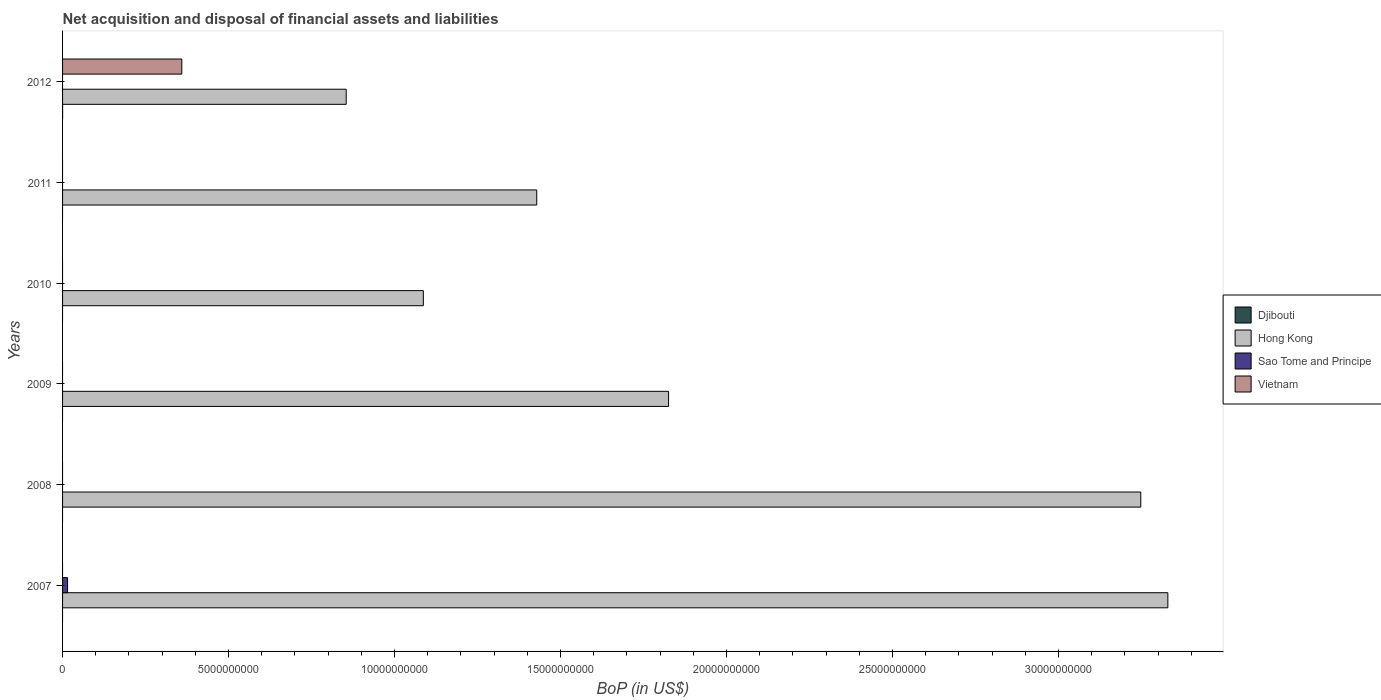Are the number of bars on each tick of the Y-axis equal?
Give a very brief answer. No. How many bars are there on the 2nd tick from the top?
Your answer should be very brief. 1. What is the label of the 2nd group of bars from the top?
Keep it short and to the point. 2011. In how many cases, is the number of bars for a given year not equal to the number of legend labels?
Ensure brevity in your answer.  6. What is the Balance of Payments in Hong Kong in 2010?
Give a very brief answer. 1.09e+1. Across all years, what is the maximum Balance of Payments in Vietnam?
Make the answer very short. 3.59e+09. Across all years, what is the minimum Balance of Payments in Hong Kong?
Offer a terse response. 8.54e+09. In which year was the Balance of Payments in Sao Tome and Principe maximum?
Keep it short and to the point. 2007. What is the total Balance of Payments in Djibouti in the graph?
Your response must be concise. 9.34e+05. What is the difference between the Balance of Payments in Hong Kong in 2007 and that in 2011?
Make the answer very short. 1.90e+1. What is the difference between the Balance of Payments in Hong Kong in 2009 and the Balance of Payments in Djibouti in 2007?
Provide a succinct answer. 1.83e+1. What is the average Balance of Payments in Sao Tome and Principe per year?
Provide a succinct answer. 2.51e+07. In how many years, is the Balance of Payments in Djibouti greater than 14000000000 US$?
Your answer should be compact. 0. What is the ratio of the Balance of Payments in Hong Kong in 2008 to that in 2011?
Your answer should be very brief. 2.27. What is the difference between the highest and the lowest Balance of Payments in Sao Tome and Principe?
Offer a terse response. 1.50e+08. Is the sum of the Balance of Payments in Hong Kong in 2008 and 2011 greater than the maximum Balance of Payments in Sao Tome and Principe across all years?
Offer a very short reply. Yes. Is it the case that in every year, the sum of the Balance of Payments in Djibouti and Balance of Payments in Hong Kong is greater than the Balance of Payments in Vietnam?
Ensure brevity in your answer.  Yes. How many bars are there?
Make the answer very short. 9. Are all the bars in the graph horizontal?
Offer a terse response. Yes. What is the difference between two consecutive major ticks on the X-axis?
Your response must be concise. 5.00e+09. Does the graph contain grids?
Offer a terse response. No. Where does the legend appear in the graph?
Give a very brief answer. Center right. How many legend labels are there?
Give a very brief answer. 4. What is the title of the graph?
Make the answer very short. Net acquisition and disposal of financial assets and liabilities. What is the label or title of the X-axis?
Make the answer very short. BoP (in US$). What is the BoP (in US$) in Hong Kong in 2007?
Provide a succinct answer. 3.33e+1. What is the BoP (in US$) in Sao Tome and Principe in 2007?
Your answer should be compact. 1.50e+08. What is the BoP (in US$) in Hong Kong in 2008?
Your response must be concise. 3.25e+1. What is the BoP (in US$) of Sao Tome and Principe in 2008?
Make the answer very short. 0. What is the BoP (in US$) in Vietnam in 2008?
Offer a very short reply. 0. What is the BoP (in US$) in Djibouti in 2009?
Ensure brevity in your answer.  0. What is the BoP (in US$) in Hong Kong in 2009?
Give a very brief answer. 1.83e+1. What is the BoP (in US$) in Vietnam in 2009?
Give a very brief answer. 0. What is the BoP (in US$) in Hong Kong in 2010?
Offer a terse response. 1.09e+1. What is the BoP (in US$) in Sao Tome and Principe in 2010?
Provide a succinct answer. 0. What is the BoP (in US$) of Djibouti in 2011?
Provide a short and direct response. 0. What is the BoP (in US$) of Hong Kong in 2011?
Offer a very short reply. 1.43e+1. What is the BoP (in US$) of Djibouti in 2012?
Give a very brief answer. 9.34e+05. What is the BoP (in US$) in Hong Kong in 2012?
Ensure brevity in your answer.  8.54e+09. What is the BoP (in US$) of Vietnam in 2012?
Give a very brief answer. 3.59e+09. Across all years, what is the maximum BoP (in US$) of Djibouti?
Your response must be concise. 9.34e+05. Across all years, what is the maximum BoP (in US$) of Hong Kong?
Your answer should be very brief. 3.33e+1. Across all years, what is the maximum BoP (in US$) of Sao Tome and Principe?
Offer a very short reply. 1.50e+08. Across all years, what is the maximum BoP (in US$) of Vietnam?
Provide a succinct answer. 3.59e+09. Across all years, what is the minimum BoP (in US$) of Djibouti?
Your answer should be compact. 0. Across all years, what is the minimum BoP (in US$) in Hong Kong?
Keep it short and to the point. 8.54e+09. Across all years, what is the minimum BoP (in US$) of Sao Tome and Principe?
Provide a short and direct response. 0. What is the total BoP (in US$) in Djibouti in the graph?
Make the answer very short. 9.34e+05. What is the total BoP (in US$) of Hong Kong in the graph?
Make the answer very short. 1.18e+11. What is the total BoP (in US$) in Sao Tome and Principe in the graph?
Provide a succinct answer. 1.50e+08. What is the total BoP (in US$) in Vietnam in the graph?
Offer a terse response. 3.59e+09. What is the difference between the BoP (in US$) in Hong Kong in 2007 and that in 2008?
Provide a succinct answer. 8.15e+08. What is the difference between the BoP (in US$) of Hong Kong in 2007 and that in 2009?
Provide a short and direct response. 1.50e+1. What is the difference between the BoP (in US$) in Hong Kong in 2007 and that in 2010?
Your answer should be compact. 2.24e+1. What is the difference between the BoP (in US$) in Hong Kong in 2007 and that in 2011?
Your response must be concise. 1.90e+1. What is the difference between the BoP (in US$) in Hong Kong in 2007 and that in 2012?
Provide a succinct answer. 2.47e+1. What is the difference between the BoP (in US$) of Hong Kong in 2008 and that in 2009?
Provide a succinct answer. 1.42e+1. What is the difference between the BoP (in US$) of Hong Kong in 2008 and that in 2010?
Offer a terse response. 2.16e+1. What is the difference between the BoP (in US$) of Hong Kong in 2008 and that in 2011?
Your answer should be very brief. 1.82e+1. What is the difference between the BoP (in US$) of Hong Kong in 2008 and that in 2012?
Give a very brief answer. 2.39e+1. What is the difference between the BoP (in US$) of Hong Kong in 2009 and that in 2010?
Give a very brief answer. 7.39e+09. What is the difference between the BoP (in US$) in Hong Kong in 2009 and that in 2011?
Your response must be concise. 3.97e+09. What is the difference between the BoP (in US$) in Hong Kong in 2009 and that in 2012?
Ensure brevity in your answer.  9.71e+09. What is the difference between the BoP (in US$) in Hong Kong in 2010 and that in 2011?
Your response must be concise. -3.42e+09. What is the difference between the BoP (in US$) in Hong Kong in 2010 and that in 2012?
Offer a very short reply. 2.32e+09. What is the difference between the BoP (in US$) of Hong Kong in 2011 and that in 2012?
Give a very brief answer. 5.74e+09. What is the difference between the BoP (in US$) in Hong Kong in 2007 and the BoP (in US$) in Vietnam in 2012?
Your answer should be compact. 2.97e+1. What is the difference between the BoP (in US$) in Sao Tome and Principe in 2007 and the BoP (in US$) in Vietnam in 2012?
Offer a very short reply. -3.44e+09. What is the difference between the BoP (in US$) in Hong Kong in 2008 and the BoP (in US$) in Vietnam in 2012?
Provide a succinct answer. 2.89e+1. What is the difference between the BoP (in US$) of Hong Kong in 2009 and the BoP (in US$) of Vietnam in 2012?
Your answer should be compact. 1.47e+1. What is the difference between the BoP (in US$) of Hong Kong in 2010 and the BoP (in US$) of Vietnam in 2012?
Keep it short and to the point. 7.28e+09. What is the difference between the BoP (in US$) in Hong Kong in 2011 and the BoP (in US$) in Vietnam in 2012?
Offer a terse response. 1.07e+1. What is the average BoP (in US$) in Djibouti per year?
Your answer should be compact. 1.56e+05. What is the average BoP (in US$) in Hong Kong per year?
Ensure brevity in your answer.  1.96e+1. What is the average BoP (in US$) in Sao Tome and Principe per year?
Offer a terse response. 2.51e+07. What is the average BoP (in US$) in Vietnam per year?
Your answer should be compact. 5.99e+08. In the year 2007, what is the difference between the BoP (in US$) in Hong Kong and BoP (in US$) in Sao Tome and Principe?
Your answer should be compact. 3.31e+1. In the year 2012, what is the difference between the BoP (in US$) of Djibouti and BoP (in US$) of Hong Kong?
Ensure brevity in your answer.  -8.54e+09. In the year 2012, what is the difference between the BoP (in US$) in Djibouti and BoP (in US$) in Vietnam?
Keep it short and to the point. -3.59e+09. In the year 2012, what is the difference between the BoP (in US$) in Hong Kong and BoP (in US$) in Vietnam?
Provide a short and direct response. 4.95e+09. What is the ratio of the BoP (in US$) of Hong Kong in 2007 to that in 2008?
Your response must be concise. 1.03. What is the ratio of the BoP (in US$) in Hong Kong in 2007 to that in 2009?
Provide a succinct answer. 1.82. What is the ratio of the BoP (in US$) of Hong Kong in 2007 to that in 2010?
Give a very brief answer. 3.06. What is the ratio of the BoP (in US$) of Hong Kong in 2007 to that in 2011?
Your response must be concise. 2.33. What is the ratio of the BoP (in US$) of Hong Kong in 2007 to that in 2012?
Your answer should be very brief. 3.9. What is the ratio of the BoP (in US$) in Hong Kong in 2008 to that in 2009?
Your response must be concise. 1.78. What is the ratio of the BoP (in US$) of Hong Kong in 2008 to that in 2010?
Provide a succinct answer. 2.99. What is the ratio of the BoP (in US$) in Hong Kong in 2008 to that in 2011?
Your answer should be compact. 2.27. What is the ratio of the BoP (in US$) in Hong Kong in 2008 to that in 2012?
Give a very brief answer. 3.8. What is the ratio of the BoP (in US$) of Hong Kong in 2009 to that in 2010?
Offer a terse response. 1.68. What is the ratio of the BoP (in US$) in Hong Kong in 2009 to that in 2011?
Give a very brief answer. 1.28. What is the ratio of the BoP (in US$) of Hong Kong in 2009 to that in 2012?
Give a very brief answer. 2.14. What is the ratio of the BoP (in US$) in Hong Kong in 2010 to that in 2011?
Offer a terse response. 0.76. What is the ratio of the BoP (in US$) in Hong Kong in 2010 to that in 2012?
Offer a terse response. 1.27. What is the ratio of the BoP (in US$) in Hong Kong in 2011 to that in 2012?
Provide a succinct answer. 1.67. What is the difference between the highest and the second highest BoP (in US$) of Hong Kong?
Provide a succinct answer. 8.15e+08. What is the difference between the highest and the lowest BoP (in US$) of Djibouti?
Your answer should be very brief. 9.34e+05. What is the difference between the highest and the lowest BoP (in US$) in Hong Kong?
Keep it short and to the point. 2.47e+1. What is the difference between the highest and the lowest BoP (in US$) of Sao Tome and Principe?
Make the answer very short. 1.50e+08. What is the difference between the highest and the lowest BoP (in US$) in Vietnam?
Offer a terse response. 3.59e+09. 